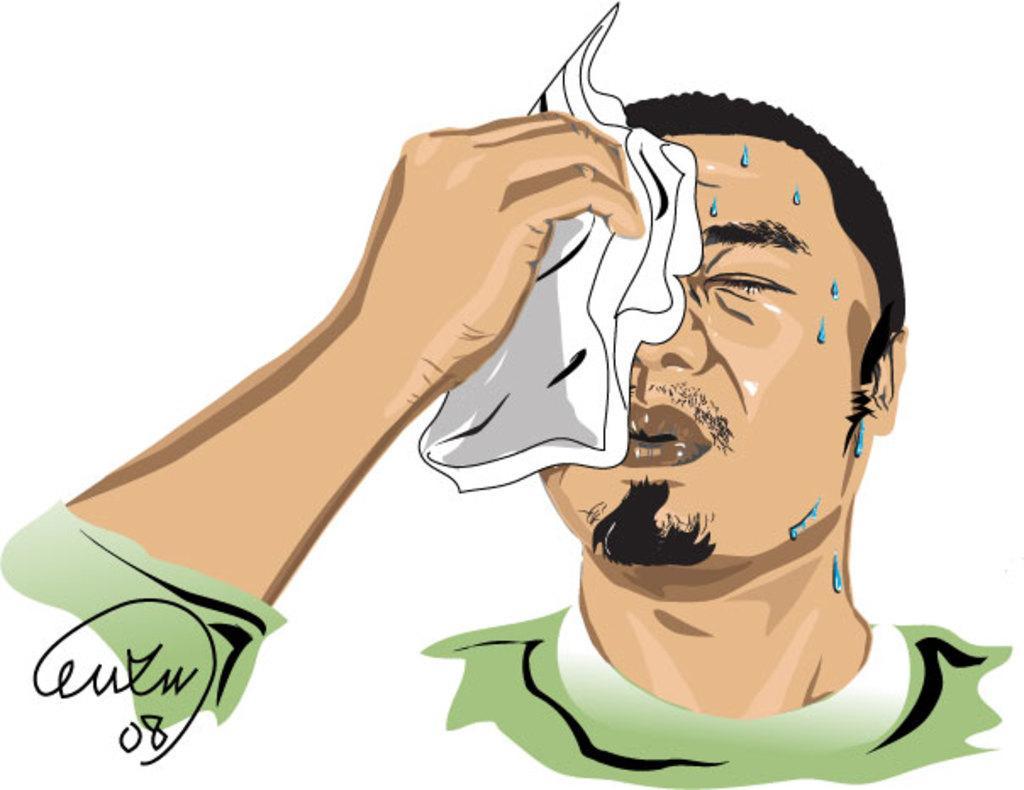In one or two sentences, can you explain what this image depicts? This is a painting. In this picture we can see a person holding handkerchief in his hand. We can see a few water droplets on this person's face. There is a text on a white surface. 